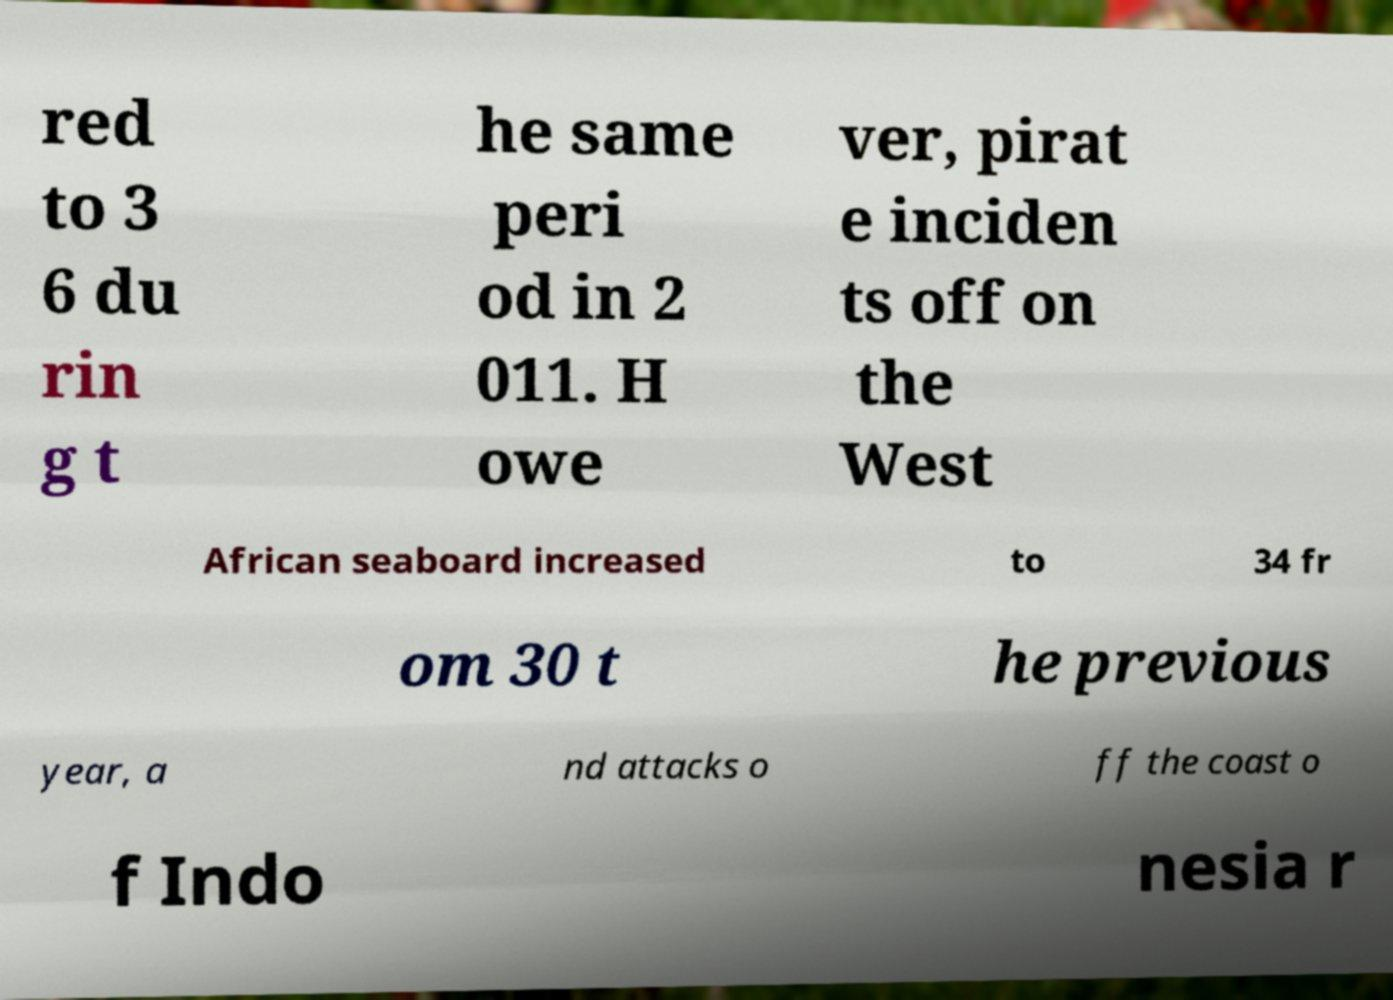I need the written content from this picture converted into text. Can you do that? red to 3 6 du rin g t he same peri od in 2 011. H owe ver, pirat e inciden ts off on the West African seaboard increased to 34 fr om 30 t he previous year, a nd attacks o ff the coast o f Indo nesia r 